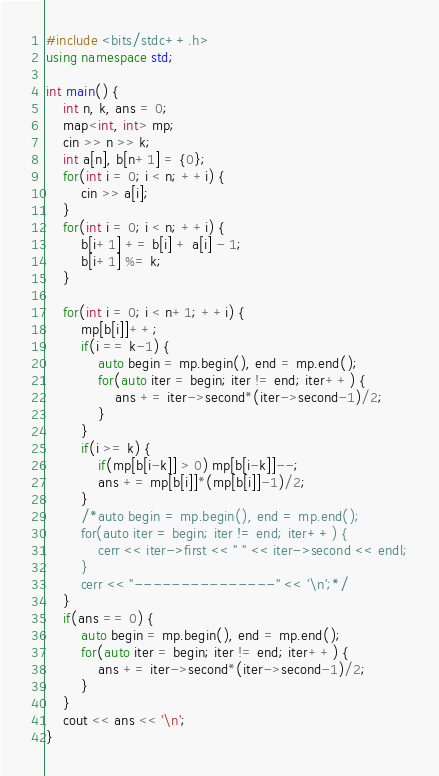<code> <loc_0><loc_0><loc_500><loc_500><_C++_>#include <bits/stdc++.h>
using namespace std;

int main() {
    int n, k, ans = 0;
    map<int, int> mp;
    cin >> n >> k;
    int a[n], b[n+1] = {0};
    for(int i = 0; i < n; ++i) {
        cin >> a[i];
    }
    for(int i = 0; i < n; ++i) {
        b[i+1] += b[i] + a[i] - 1;
        b[i+1] %= k;
    }

    for(int i = 0; i < n+1; ++i) {
        mp[b[i]]++;
        if(i == k-1) {
            auto begin = mp.begin(), end = mp.end();
            for(auto iter = begin; iter != end; iter++) {
                ans += iter->second*(iter->second-1)/2;
            }
        }
        if(i >= k) {
            if(mp[b[i-k]] > 0) mp[b[i-k]]--;
            ans += mp[b[i]]*(mp[b[i]]-1)/2;
        }
        /*auto begin = mp.begin(), end = mp.end();
        for(auto iter = begin; iter != end; iter++) {
            cerr << iter->first << " " << iter->second << endl;
        }
        cerr << "---------------" << '\n';*/
    }
    if(ans == 0) {
        auto begin = mp.begin(), end = mp.end();
        for(auto iter = begin; iter != end; iter++) {
            ans += iter->second*(iter->second-1)/2;
        }
    }
    cout << ans << '\n';
}
</code> 